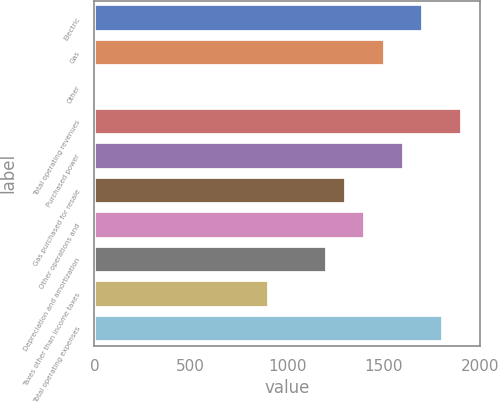<chart> <loc_0><loc_0><loc_500><loc_500><bar_chart><fcel>Electric<fcel>Gas<fcel>Other<fcel>Total operating revenues<fcel>Purchased power<fcel>Gas purchased for resale<fcel>Other operations and<fcel>Depreciation and amortization<fcel>Taxes other than income taxes<fcel>Total operating expenses<nl><fcel>1706.4<fcel>1506<fcel>3<fcel>1906.8<fcel>1606.2<fcel>1305.6<fcel>1405.8<fcel>1205.4<fcel>904.8<fcel>1806.6<nl></chart> 